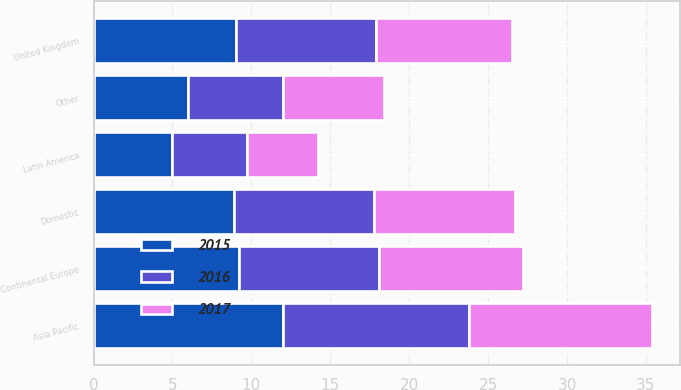Convert chart. <chart><loc_0><loc_0><loc_500><loc_500><stacked_bar_chart><ecel><fcel>Domestic<fcel>United Kingdom<fcel>Continental Europe<fcel>Asia Pacific<fcel>Latin America<fcel>Other<nl><fcel>2017<fcel>8.9<fcel>8.6<fcel>9.1<fcel>11.6<fcel>4.5<fcel>6.4<nl><fcel>2016<fcel>8.9<fcel>8.9<fcel>8.9<fcel>11.8<fcel>4.7<fcel>6<nl><fcel>2015<fcel>8.9<fcel>9<fcel>9.2<fcel>12<fcel>5<fcel>6<nl></chart> 